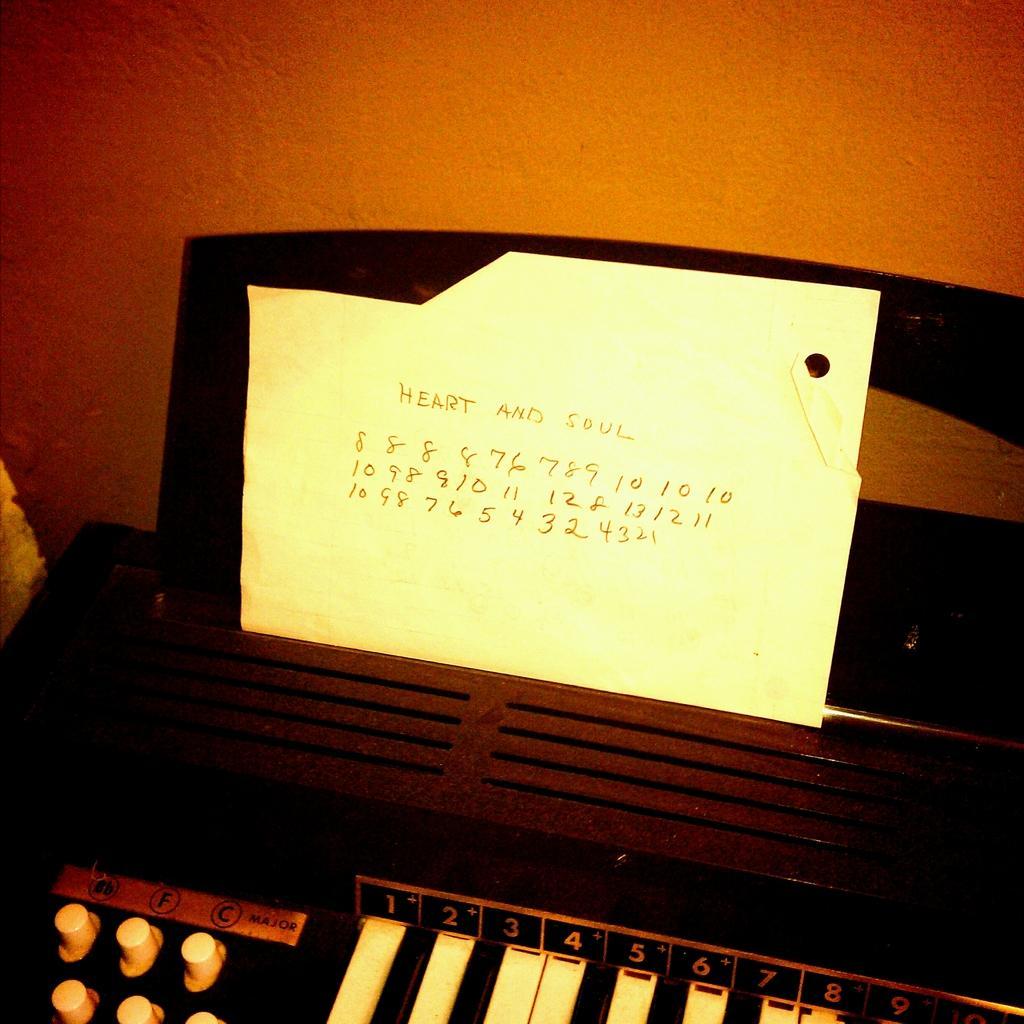Please provide a concise description of this image. In the image we can see there is a music instrument and on it there is a paper kept on which its written "Heart and Soul". 